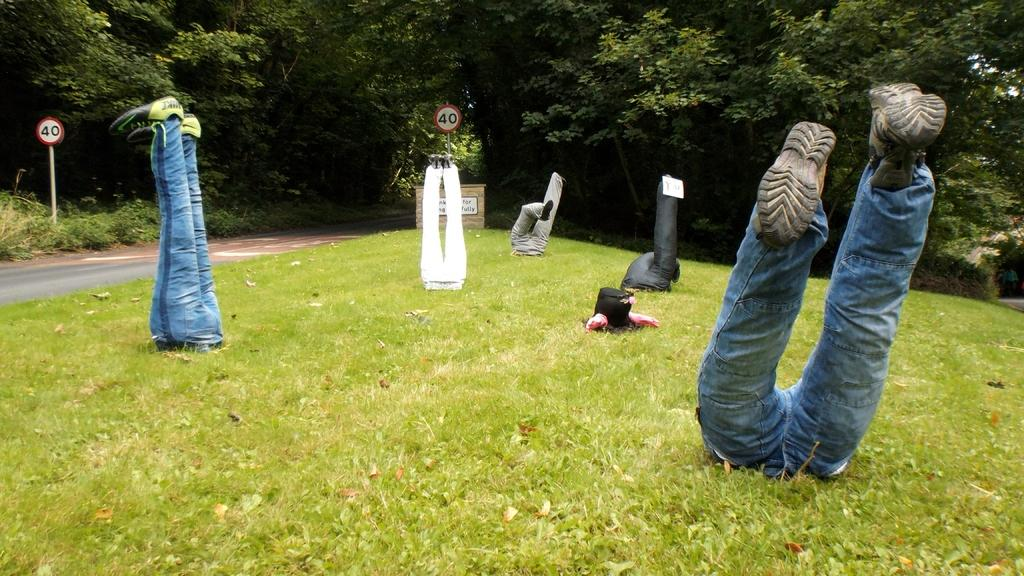What can be seen at the bottom of the image? There are legs of some persons visible in the image. What type of informational signs are present in the image? There are sign boards in the image. What is the name of the place or establishment in the image? There is a name board in the image. What type of pathway is visible in the image? There is a road in the image. What type of vegetation is present in the image? There is grass in the image}. What type of vegetation is present in the image? There are plants in the image. What can be seen in the background of the image? There are trees visible in the background of the image. How does the egg fly in the image? There is no egg present in the image, so it cannot fly. What type of transport is visible in the image? The image does not show any specific mode of transport; it only shows legs, sign boards, a name board, a road, grass, plants, and trees. 